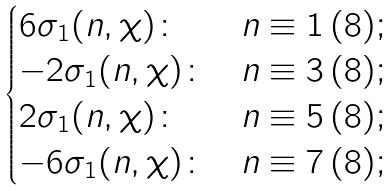Convert formula to latex. <formula><loc_0><loc_0><loc_500><loc_500>\begin{cases} 6 \sigma _ { 1 } ( n , \chi ) \colon & n \equiv 1 \, ( 8 ) ; \\ - 2 \sigma _ { 1 } ( n , \chi ) \colon & n \equiv 3 \, ( 8 ) ; \\ 2 \sigma _ { 1 } ( n , \chi ) \colon & n \equiv 5 \, ( 8 ) ; \\ - 6 \sigma _ { 1 } ( n , \chi ) \colon & n \equiv 7 \, ( 8 ) ; \end{cases}</formula> 